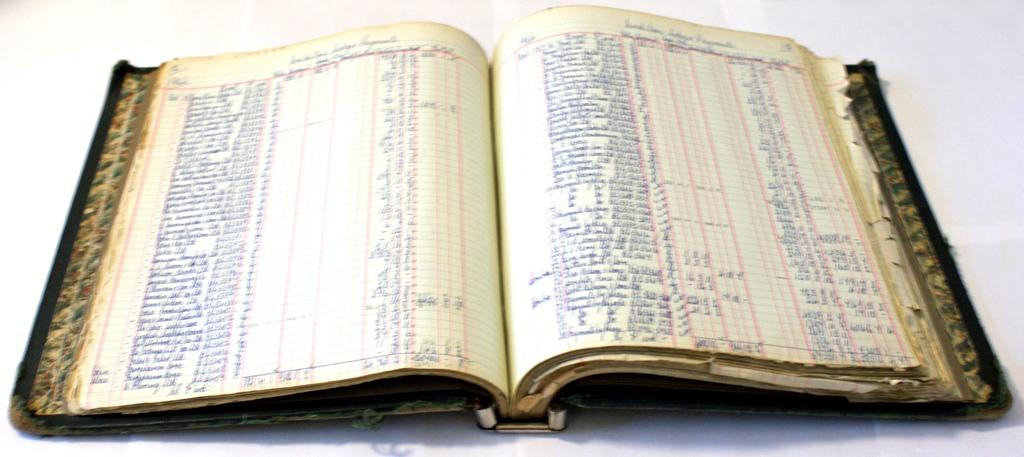What is present in the image related to reading material? There is a book in the image. Can you describe the state of the book in the image? The book is opened. What can be observed about the content of the book? There is a lot of text in the book. What type of quilt is being used to cover the book in the image? There is no quilt present in the image; the book is opened and does not have a quilt covering it. 